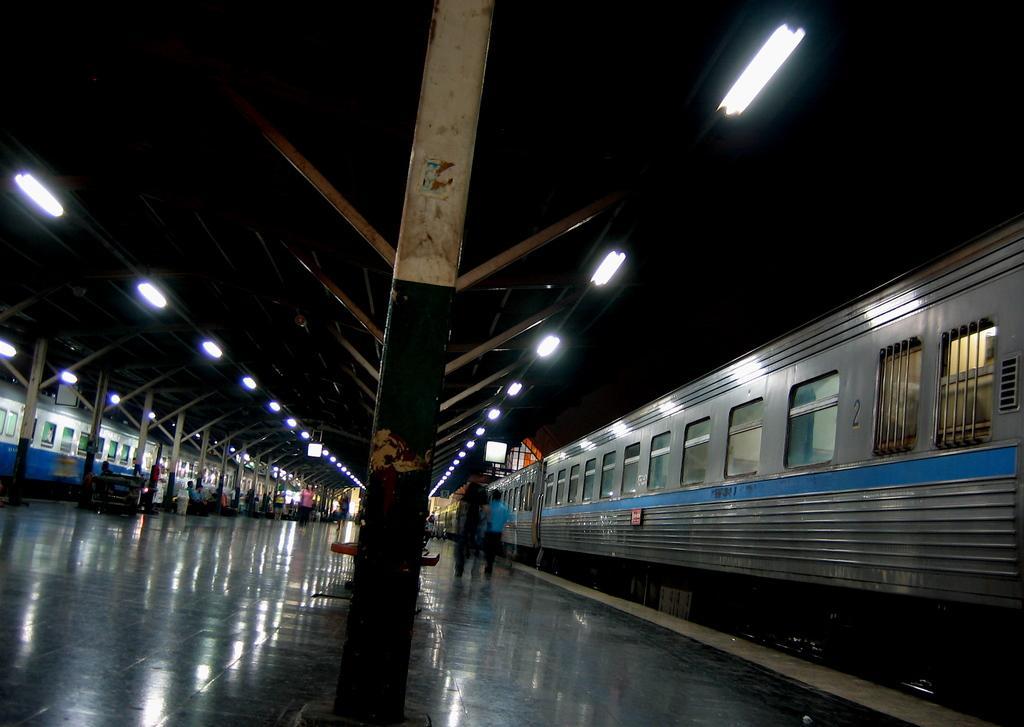How would you summarize this image in a sentence or two? I think this picture was taken in the railway station. There are two trains. These are the tube lights. I can see few people sitting and few people standing. This is a platform. 